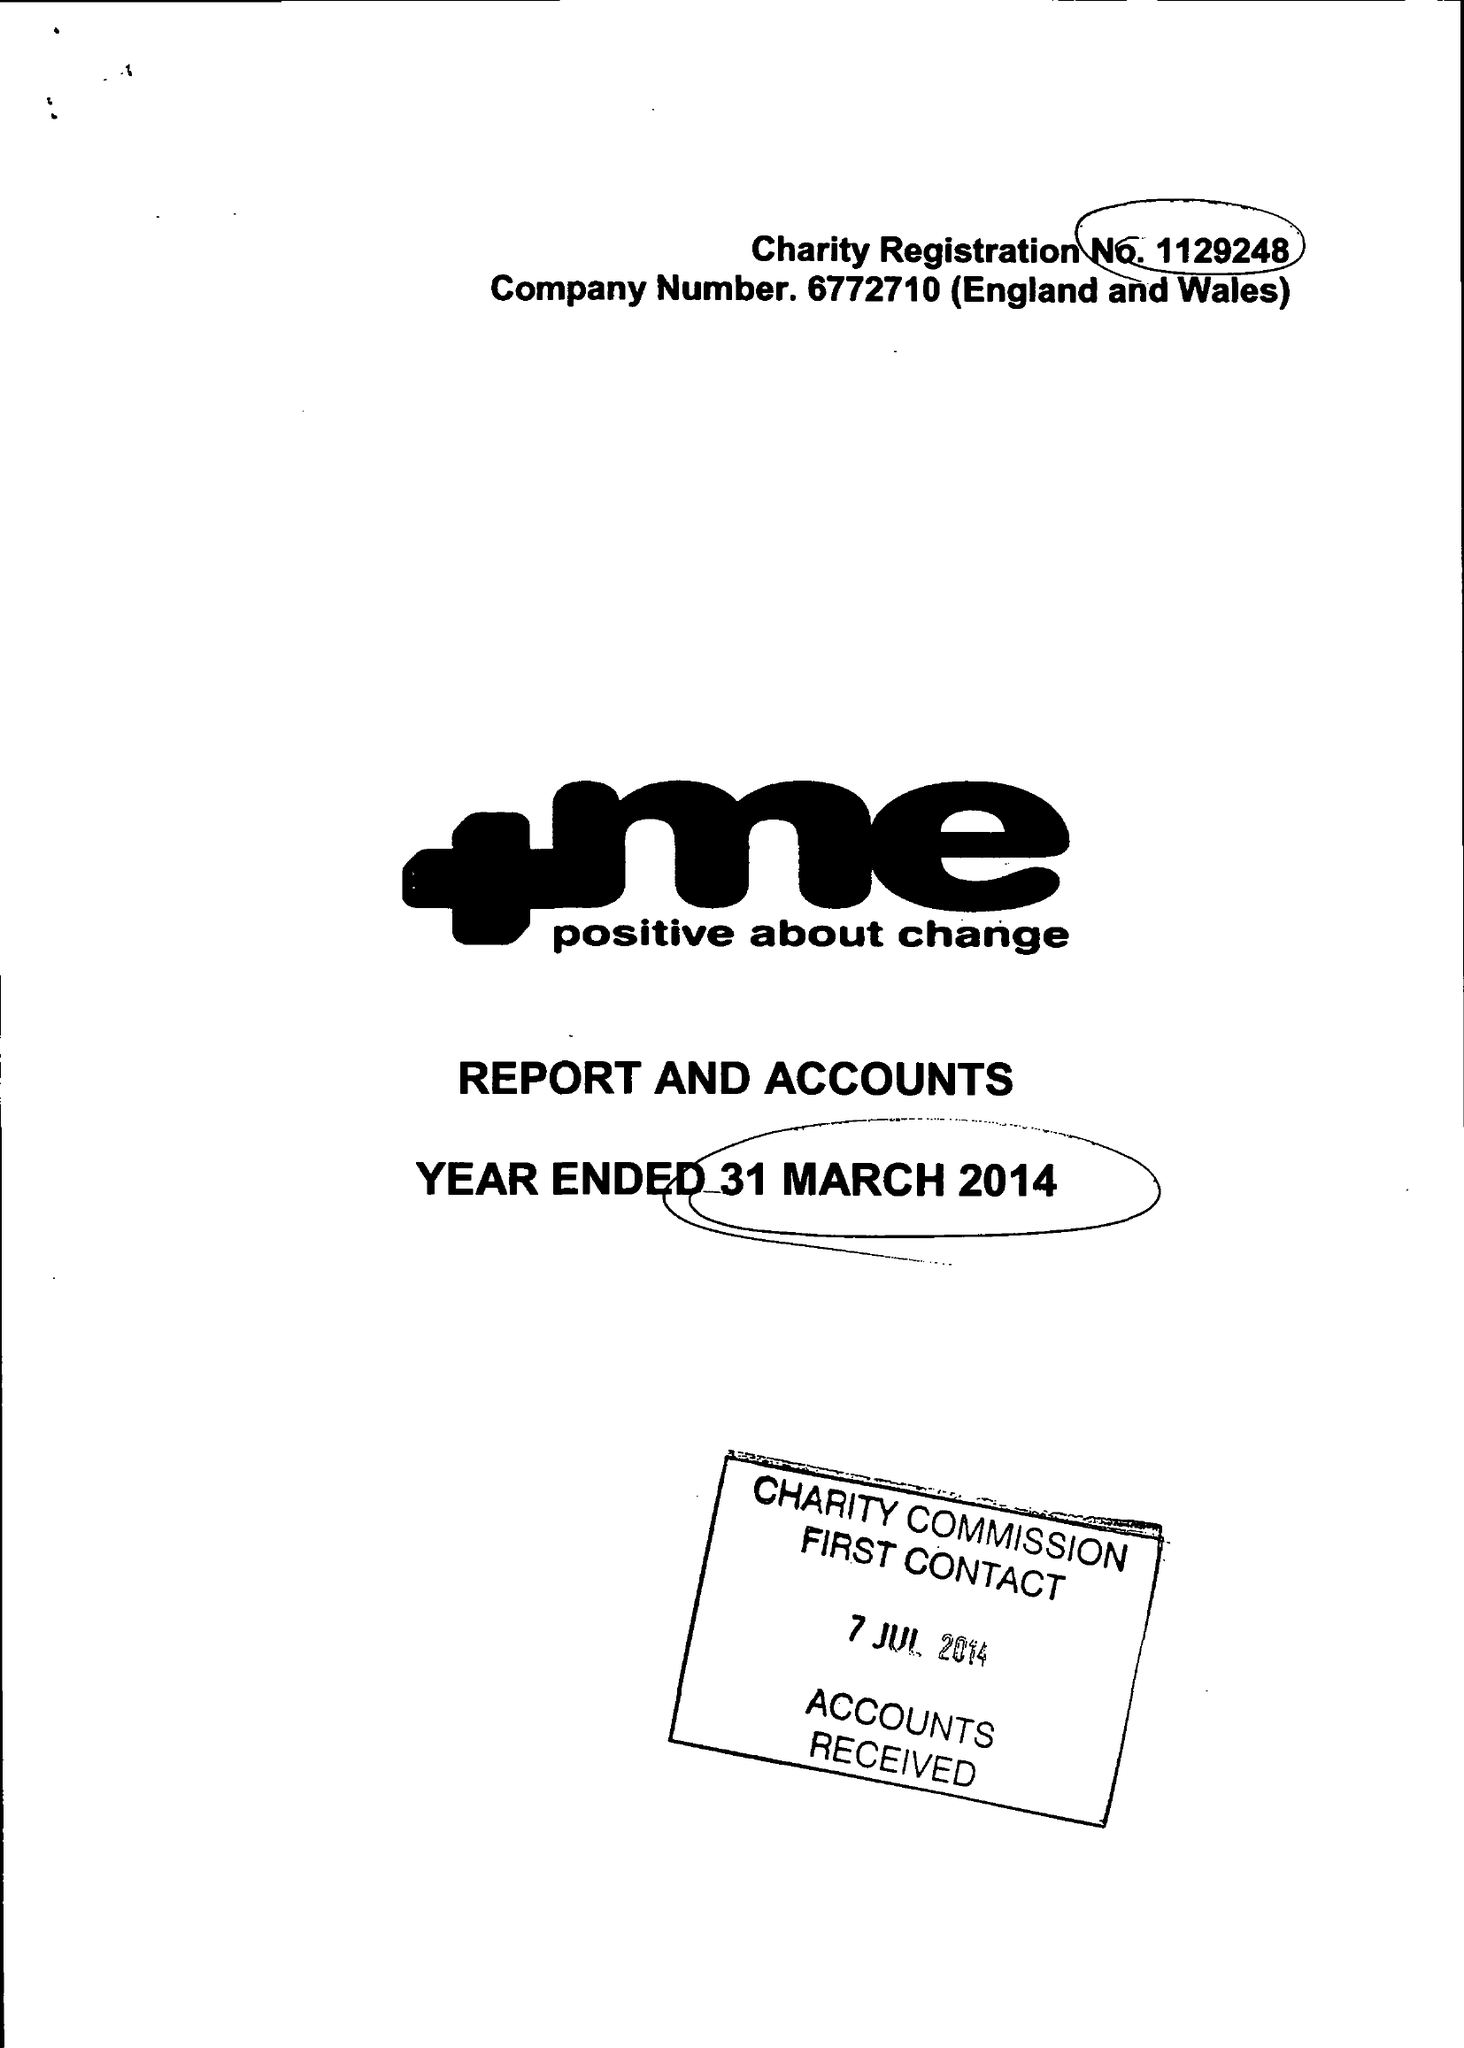What is the value for the spending_annually_in_british_pounds?
Answer the question using a single word or phrase. 88032.00 